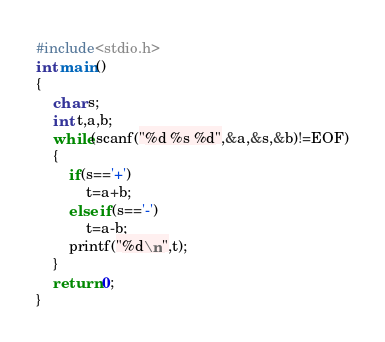<code> <loc_0><loc_0><loc_500><loc_500><_C_>#include<stdio.h>
int main()
{
	char s;
	int t,a,b;
	while(scanf("%d %s %d",&a,&s,&b)!=EOF)
	{
		if(s=='+')
			t=a+b;
		else if(s=='-')
			t=a-b;
		printf("%d\n",t);
	}
	return 0;
}</code> 